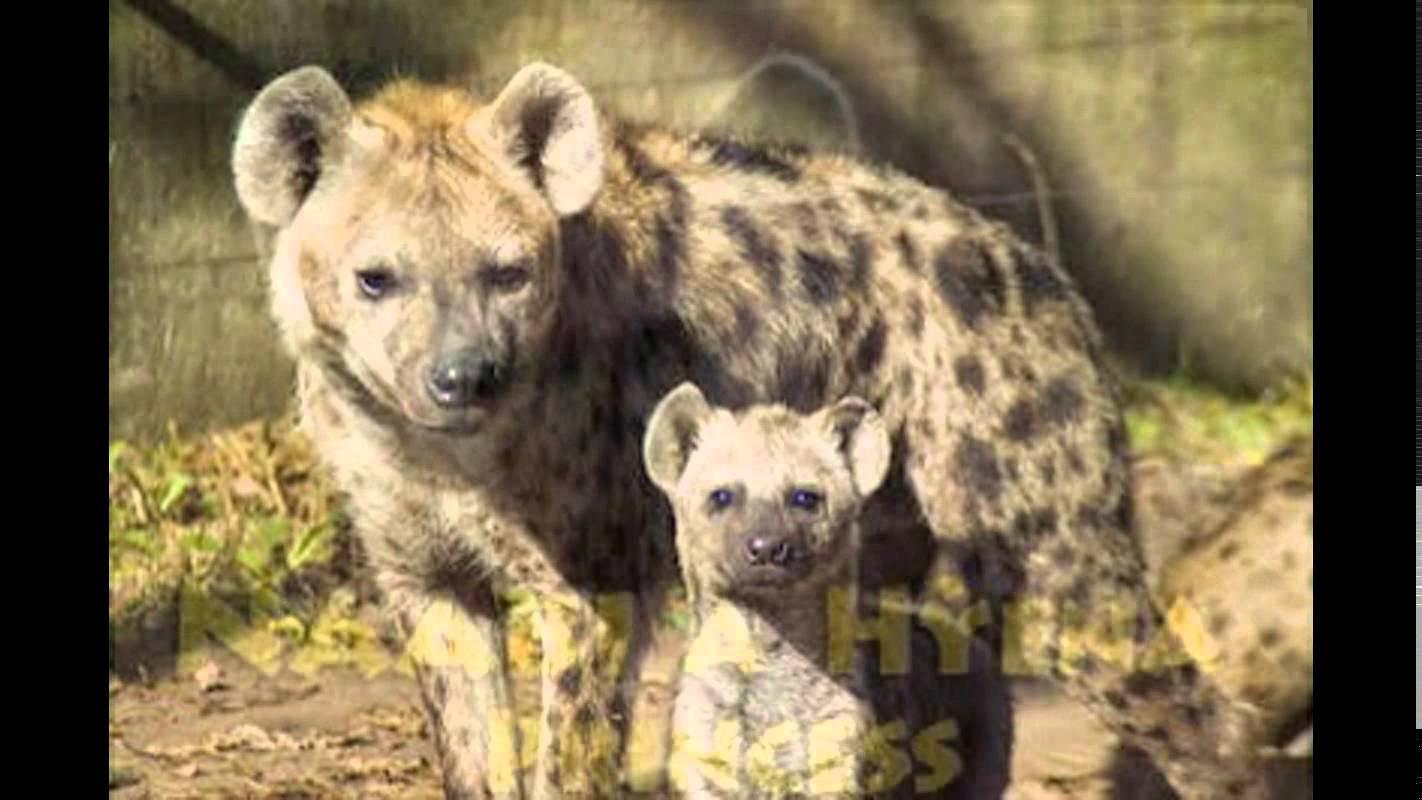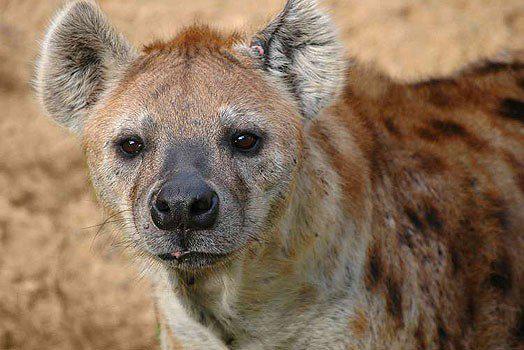The first image is the image on the left, the second image is the image on the right. For the images displayed, is the sentence "One standing animal with a black nose is looking forward in the right image." factually correct? Answer yes or no. Yes. The first image is the image on the left, the second image is the image on the right. Examine the images to the left and right. Is the description "The image on the left shows 2 animals both looking in the same direction." accurate? Answer yes or no. Yes. 